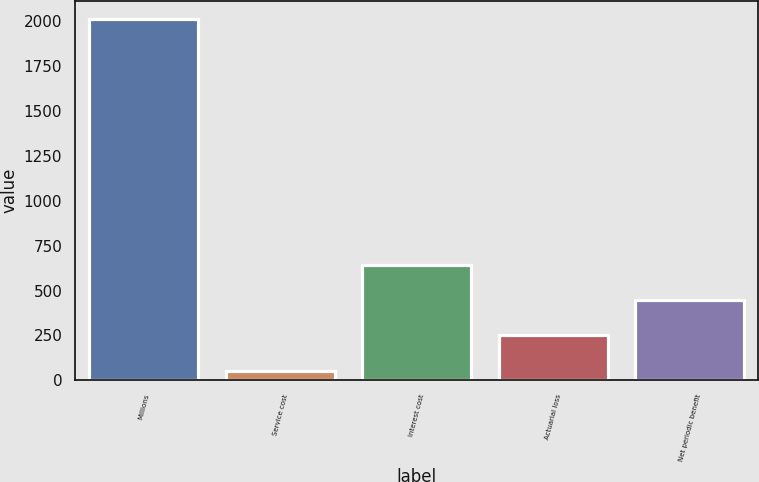<chart> <loc_0><loc_0><loc_500><loc_500><bar_chart><fcel>Millions<fcel>Service cost<fcel>Interest cost<fcel>Actuarial loss<fcel>Net periodic benefit<nl><fcel>2012<fcel>54<fcel>641.4<fcel>249.8<fcel>445.6<nl></chart> 